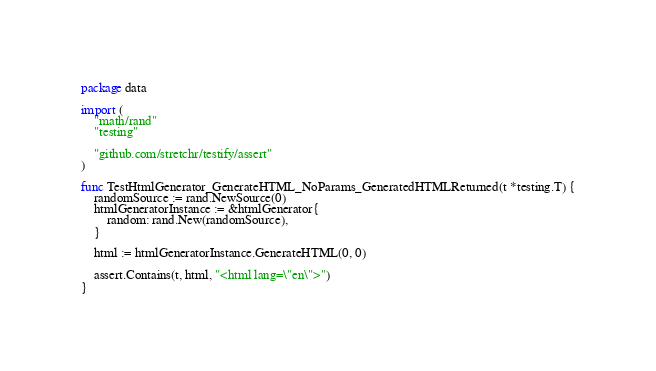<code> <loc_0><loc_0><loc_500><loc_500><_Go_>package data

import (
	"math/rand"
	"testing"

	"github.com/stretchr/testify/assert"
)

func TestHtmlGenerator_GenerateHTML_NoParams_GeneratedHTMLReturned(t *testing.T) {
	randomSource := rand.NewSource(0)
	htmlGeneratorInstance := &htmlGenerator{
		random: rand.New(randomSource),
	}

	html := htmlGeneratorInstance.GenerateHTML(0, 0)

	assert.Contains(t, html, "<html lang=\"en\">")
}
</code> 